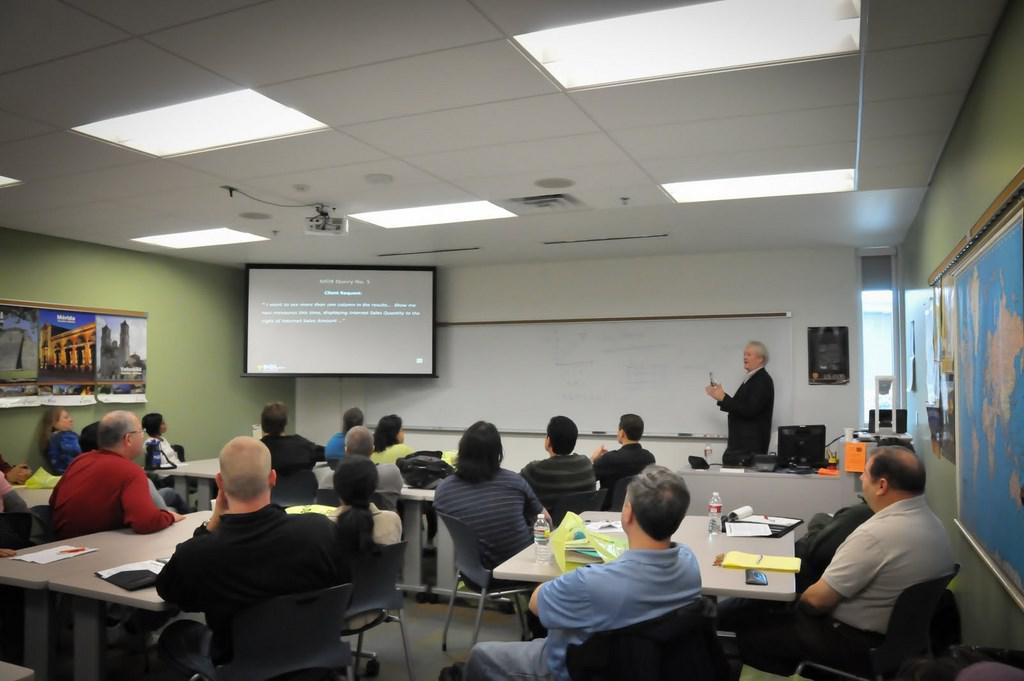What is the main subject of the image? The main subject of the image is a group of people. What are the people doing in the image? The people are sitting on chairs in the image. What is present on the table in the image? There is a paper on the table in the image. What can be seen at the back side of the image? There is a screen at the back side of the image. How many cushions are placed on the chairs in the image? There is no mention of cushions on the chairs in the image. 